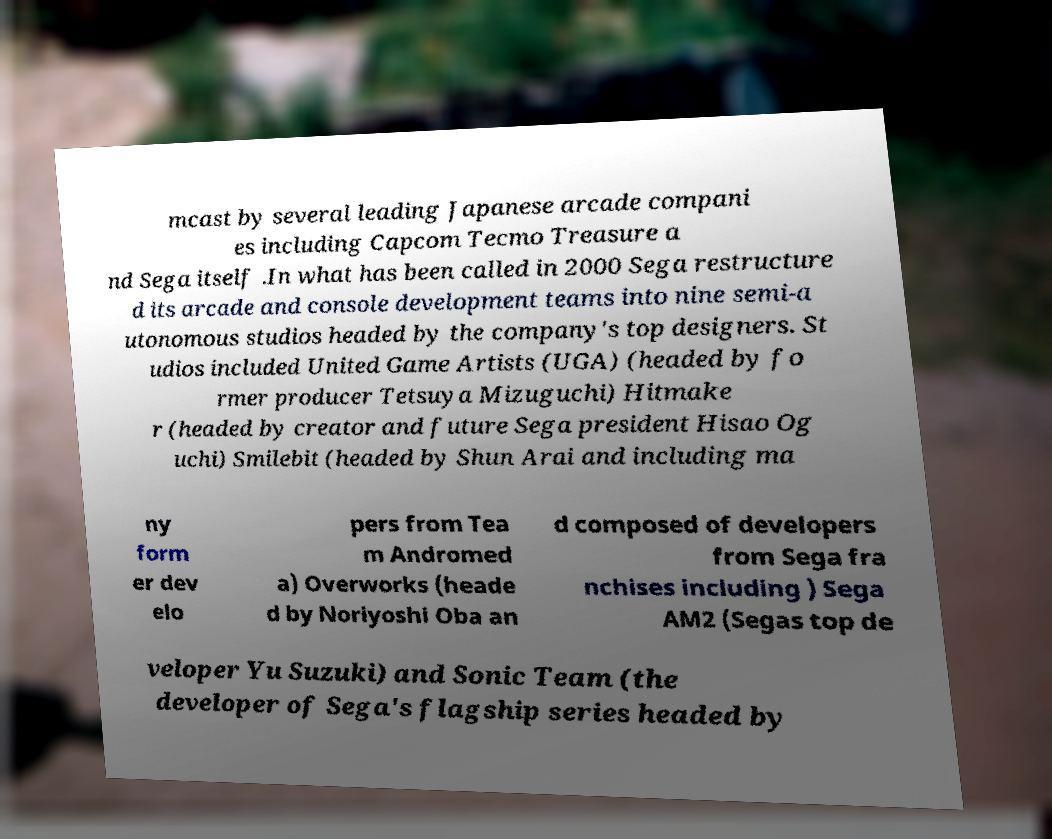I need the written content from this picture converted into text. Can you do that? mcast by several leading Japanese arcade compani es including Capcom Tecmo Treasure a nd Sega itself .In what has been called in 2000 Sega restructure d its arcade and console development teams into nine semi-a utonomous studios headed by the company's top designers. St udios included United Game Artists (UGA) (headed by fo rmer producer Tetsuya Mizuguchi) Hitmake r (headed by creator and future Sega president Hisao Og uchi) Smilebit (headed by Shun Arai and including ma ny form er dev elo pers from Tea m Andromed a) Overworks (heade d by Noriyoshi Oba an d composed of developers from Sega fra nchises including ) Sega AM2 (Segas top de veloper Yu Suzuki) and Sonic Team (the developer of Sega's flagship series headed by 